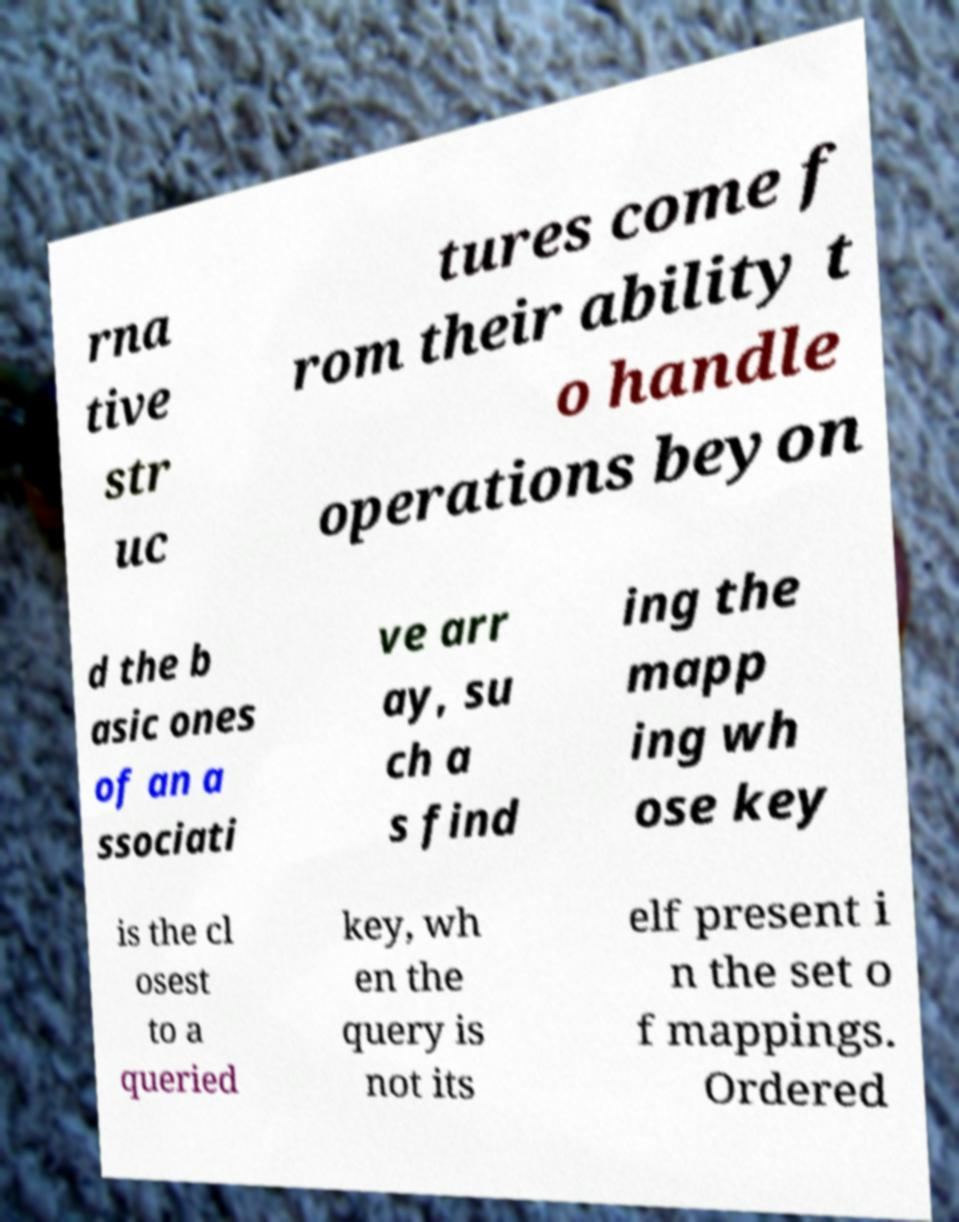For documentation purposes, I need the text within this image transcribed. Could you provide that? rna tive str uc tures come f rom their ability t o handle operations beyon d the b asic ones of an a ssociati ve arr ay, su ch a s find ing the mapp ing wh ose key is the cl osest to a queried key, wh en the query is not its elf present i n the set o f mappings. Ordered 